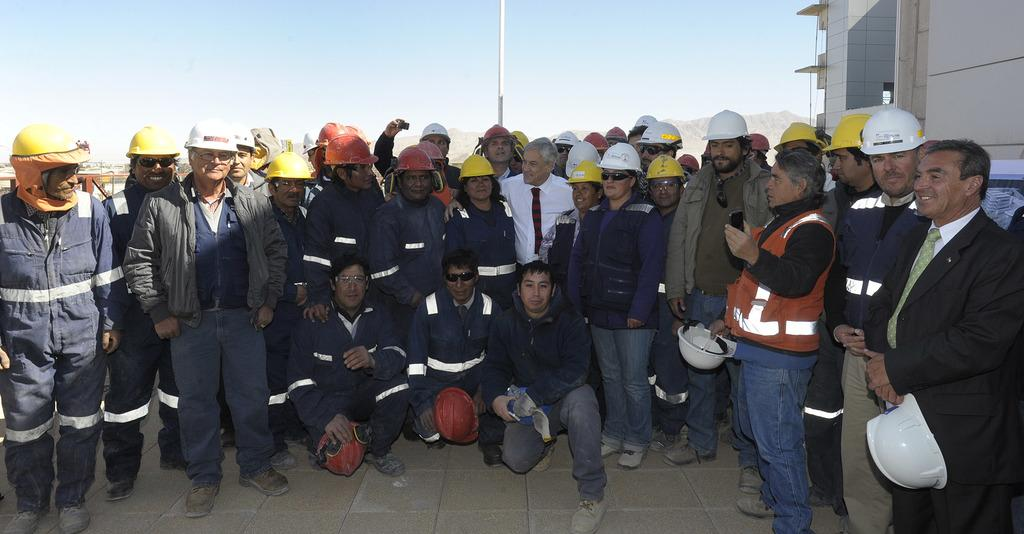What is happening on the floor in the image? There is a group of people visible on the floor. What can be seen in the middle of the image? There is a pole in the middle of the image. What is visible at the top of the image? The sky is visible at the top of the image. Can you describe any structures or buildings in the image? There may be a building in the top right of the image. What color is the shirt worn by the coast in the image? There is no coast or shirt present in the image. Is there a coil visible on the pole in the image? There is no coil visible on the pole in the image. 